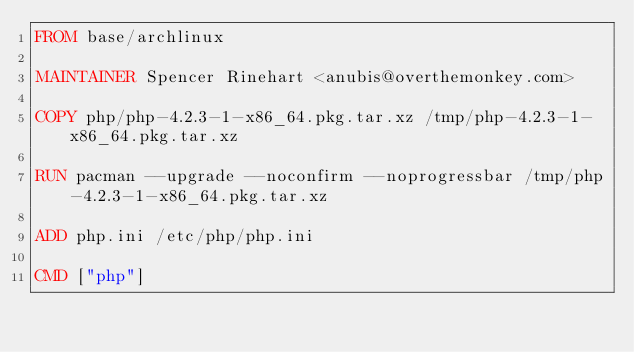Convert code to text. <code><loc_0><loc_0><loc_500><loc_500><_Dockerfile_>FROM base/archlinux

MAINTAINER Spencer Rinehart <anubis@overthemonkey.com>

COPY php/php-4.2.3-1-x86_64.pkg.tar.xz /tmp/php-4.2.3-1-x86_64.pkg.tar.xz

RUN pacman --upgrade --noconfirm --noprogressbar /tmp/php-4.2.3-1-x86_64.pkg.tar.xz

ADD php.ini /etc/php/php.ini

CMD ["php"]
</code> 